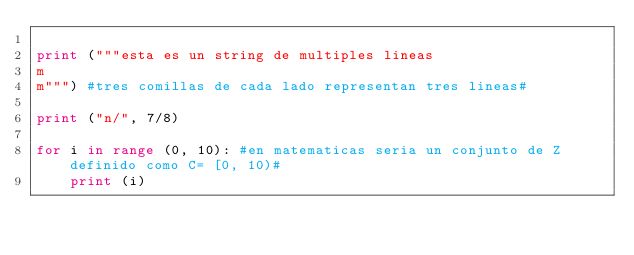Convert code to text. <code><loc_0><loc_0><loc_500><loc_500><_Python_>
print ("""esta es un string de multiples lineas
m
m""") #tres comillas de cada lado representan tres lineas#

print ("n/", 7/8)

for i in range (0, 10): #en matematicas seria un conjunto de Z definido como C= [0, 10)#
    print (i) </code> 